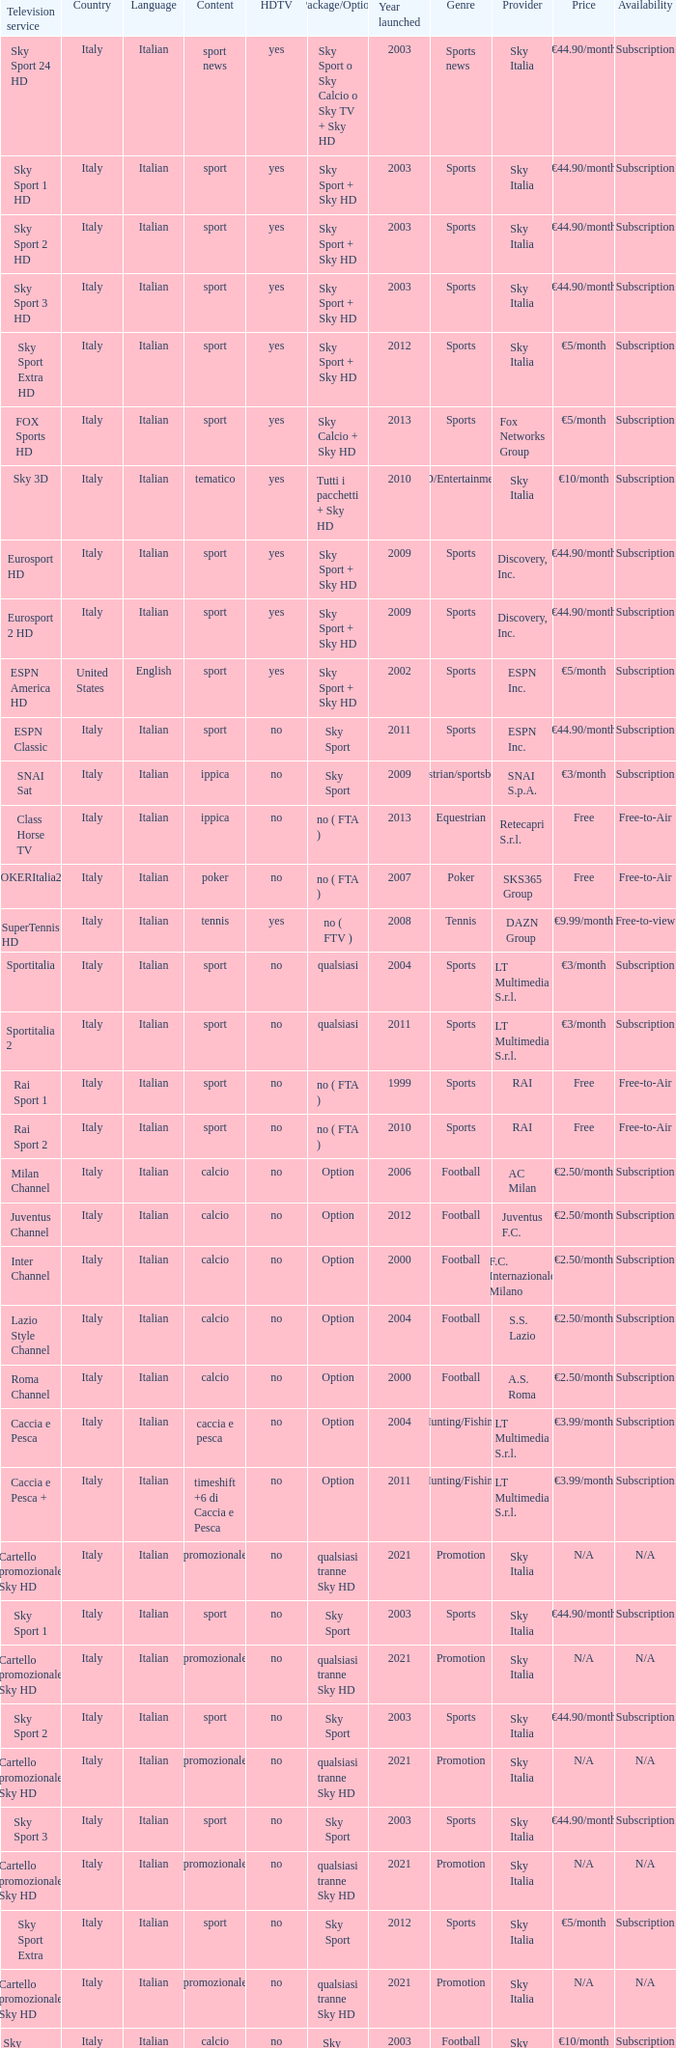What is Country, when Television Service is Eurosport 2? Italy. 